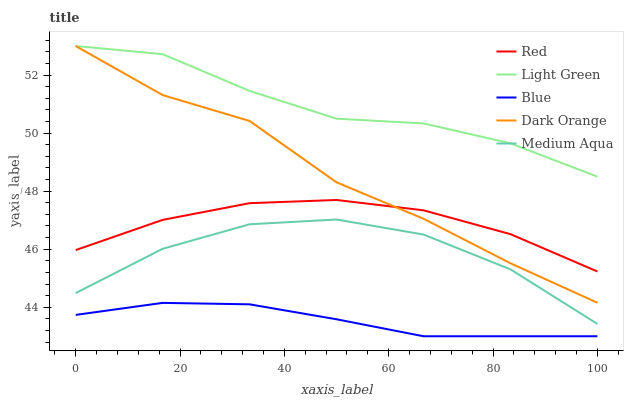Does Blue have the minimum area under the curve?
Answer yes or no. Yes. Does Light Green have the maximum area under the curve?
Answer yes or no. Yes. Does Dark Orange have the minimum area under the curve?
Answer yes or no. No. Does Dark Orange have the maximum area under the curve?
Answer yes or no. No. Is Blue the smoothest?
Answer yes or no. Yes. Is Medium Aqua the roughest?
Answer yes or no. Yes. Is Dark Orange the smoothest?
Answer yes or no. No. Is Dark Orange the roughest?
Answer yes or no. No. Does Blue have the lowest value?
Answer yes or no. Yes. Does Dark Orange have the lowest value?
Answer yes or no. No. Does Light Green have the highest value?
Answer yes or no. Yes. Does Medium Aqua have the highest value?
Answer yes or no. No. Is Medium Aqua less than Dark Orange?
Answer yes or no. Yes. Is Red greater than Medium Aqua?
Answer yes or no. Yes. Does Red intersect Dark Orange?
Answer yes or no. Yes. Is Red less than Dark Orange?
Answer yes or no. No. Is Red greater than Dark Orange?
Answer yes or no. No. Does Medium Aqua intersect Dark Orange?
Answer yes or no. No. 